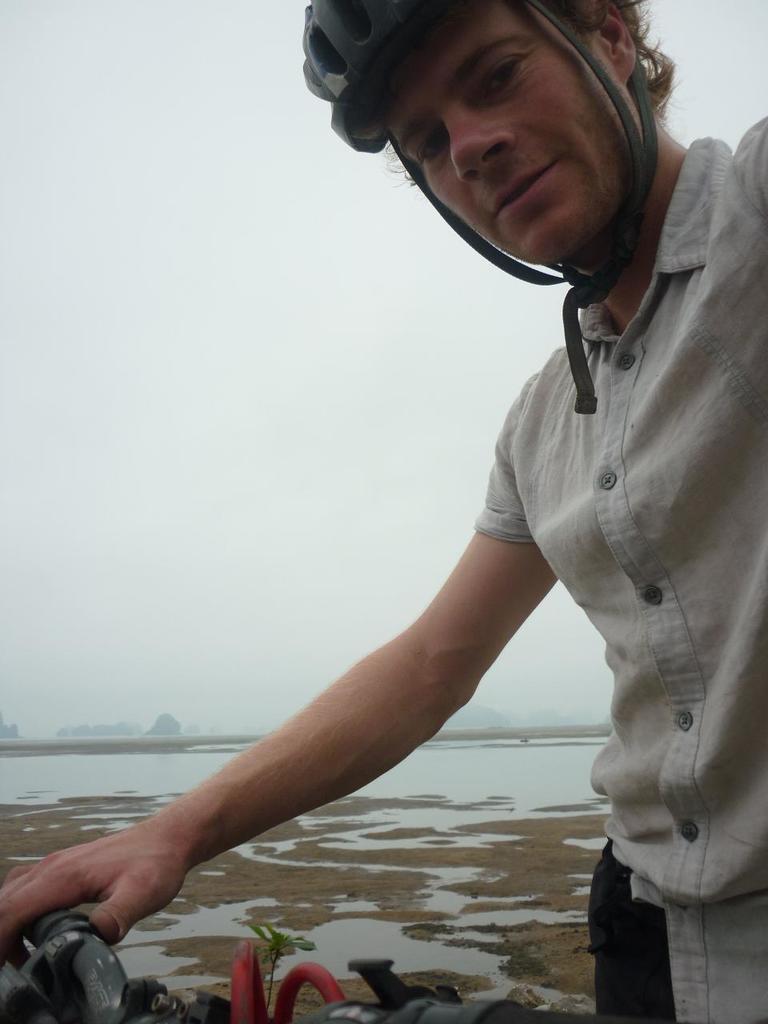How would you summarize this image in a sentence or two? In this image I can see a person wearing shirt, black pant and black helmet is holding a bicycle which is black in color. In the background I can see the ground, the water and the sky. 